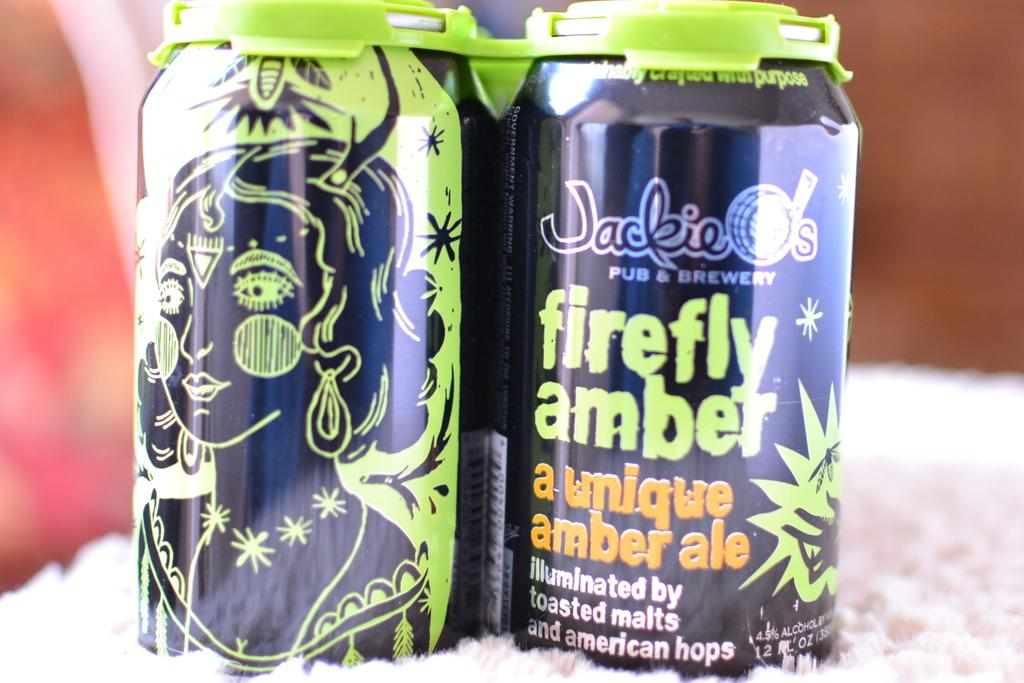<image>
Offer a succinct explanation of the picture presented. two cans of Jackie O's firefly amber sit on a table 